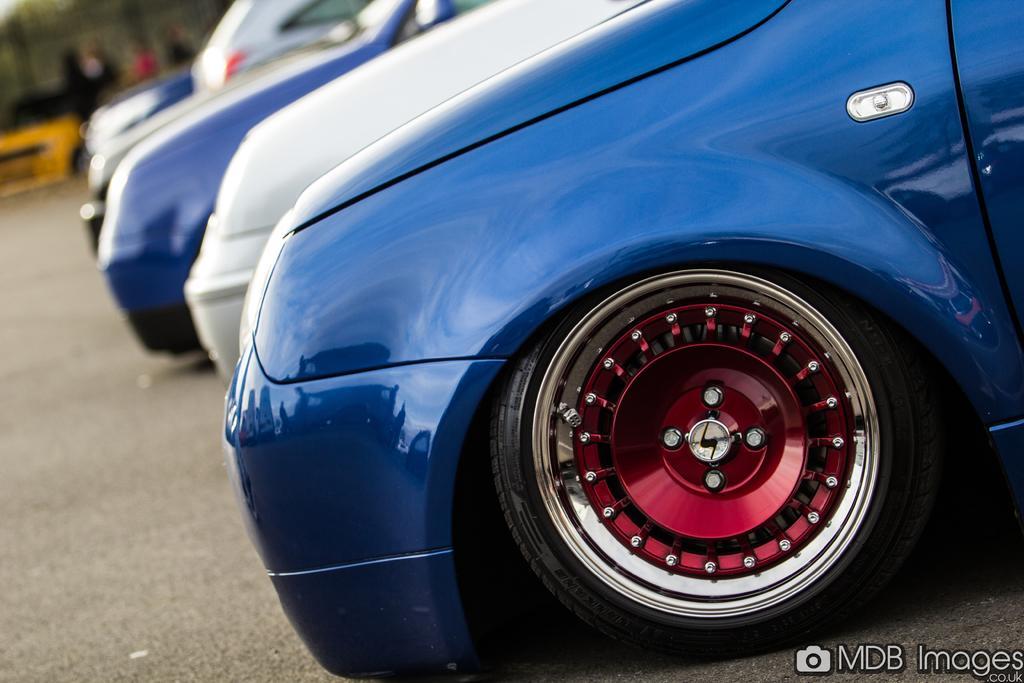Could you give a brief overview of what you see in this image? In this image, we can see cars on the road and in the background, there are people. At the bottom, there is some text and a logo. 